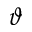Convert formula to latex. <formula><loc_0><loc_0><loc_500><loc_500>\vartheta</formula> 